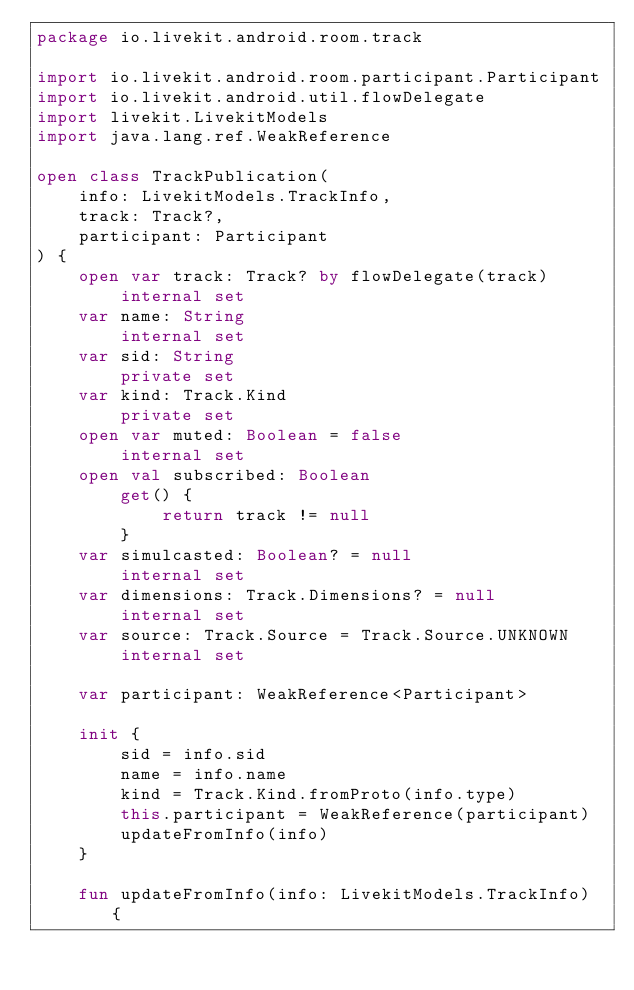Convert code to text. <code><loc_0><loc_0><loc_500><loc_500><_Kotlin_>package io.livekit.android.room.track

import io.livekit.android.room.participant.Participant
import io.livekit.android.util.flowDelegate
import livekit.LivekitModels
import java.lang.ref.WeakReference

open class TrackPublication(
    info: LivekitModels.TrackInfo,
    track: Track?,
    participant: Participant
) {
    open var track: Track? by flowDelegate(track)
        internal set
    var name: String
        internal set
    var sid: String
        private set
    var kind: Track.Kind
        private set
    open var muted: Boolean = false
        internal set
    open val subscribed: Boolean
        get() {
            return track != null
        }
    var simulcasted: Boolean? = null
        internal set
    var dimensions: Track.Dimensions? = null
        internal set
    var source: Track.Source = Track.Source.UNKNOWN
        internal set

    var participant: WeakReference<Participant>

    init {
        sid = info.sid
        name = info.name
        kind = Track.Kind.fromProto(info.type)
        this.participant = WeakReference(participant)
        updateFromInfo(info)
    }

    fun updateFromInfo(info: LivekitModels.TrackInfo) {</code> 